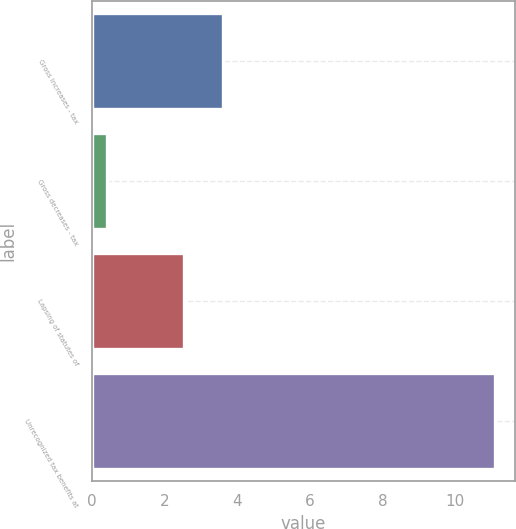Convert chart. <chart><loc_0><loc_0><loc_500><loc_500><bar_chart><fcel>Gross increases - tax<fcel>Gross decreases - tax<fcel>Lapsing of statutes of<fcel>Unrecognized tax benefits at<nl><fcel>3.61<fcel>0.4<fcel>2.54<fcel>11.1<nl></chart> 